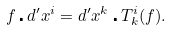<formula> <loc_0><loc_0><loc_500><loc_500>f \centerdot d ^ { \prime } x ^ { i } = d ^ { \prime } x ^ { k } \centerdot T ^ { i } _ { k } ( f ) .</formula> 